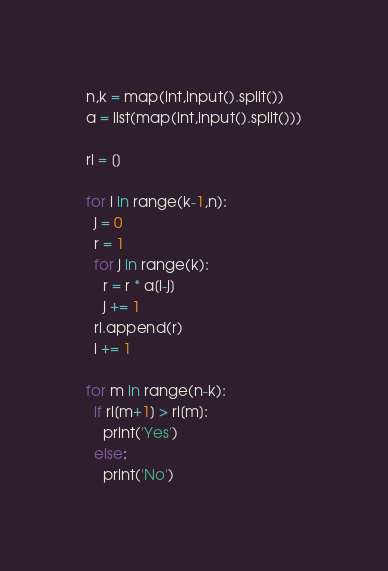<code> <loc_0><loc_0><loc_500><loc_500><_Python_>n,k = map(int,input().split())
a = list(map(int,input().split()))

rl = []

for i in range(k-1,n):
  j = 0
  r = 1
  for j in range(k):
    r = r * a[i-j]
    j += 1
  rl.append(r)
  i += 1

for m in range(n-k):
  if rl[m+1] > rl[m]:
    print('Yes')
  else:
    print('No')</code> 